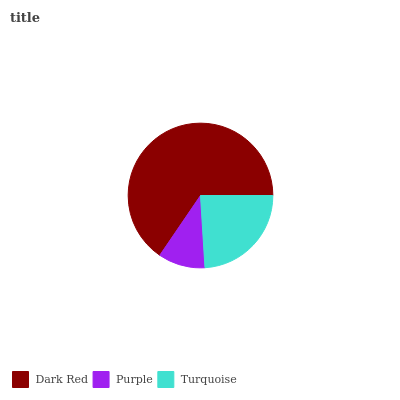Is Purple the minimum?
Answer yes or no. Yes. Is Dark Red the maximum?
Answer yes or no. Yes. Is Turquoise the minimum?
Answer yes or no. No. Is Turquoise the maximum?
Answer yes or no. No. Is Turquoise greater than Purple?
Answer yes or no. Yes. Is Purple less than Turquoise?
Answer yes or no. Yes. Is Purple greater than Turquoise?
Answer yes or no. No. Is Turquoise less than Purple?
Answer yes or no. No. Is Turquoise the high median?
Answer yes or no. Yes. Is Turquoise the low median?
Answer yes or no. Yes. Is Dark Red the high median?
Answer yes or no. No. Is Dark Red the low median?
Answer yes or no. No. 